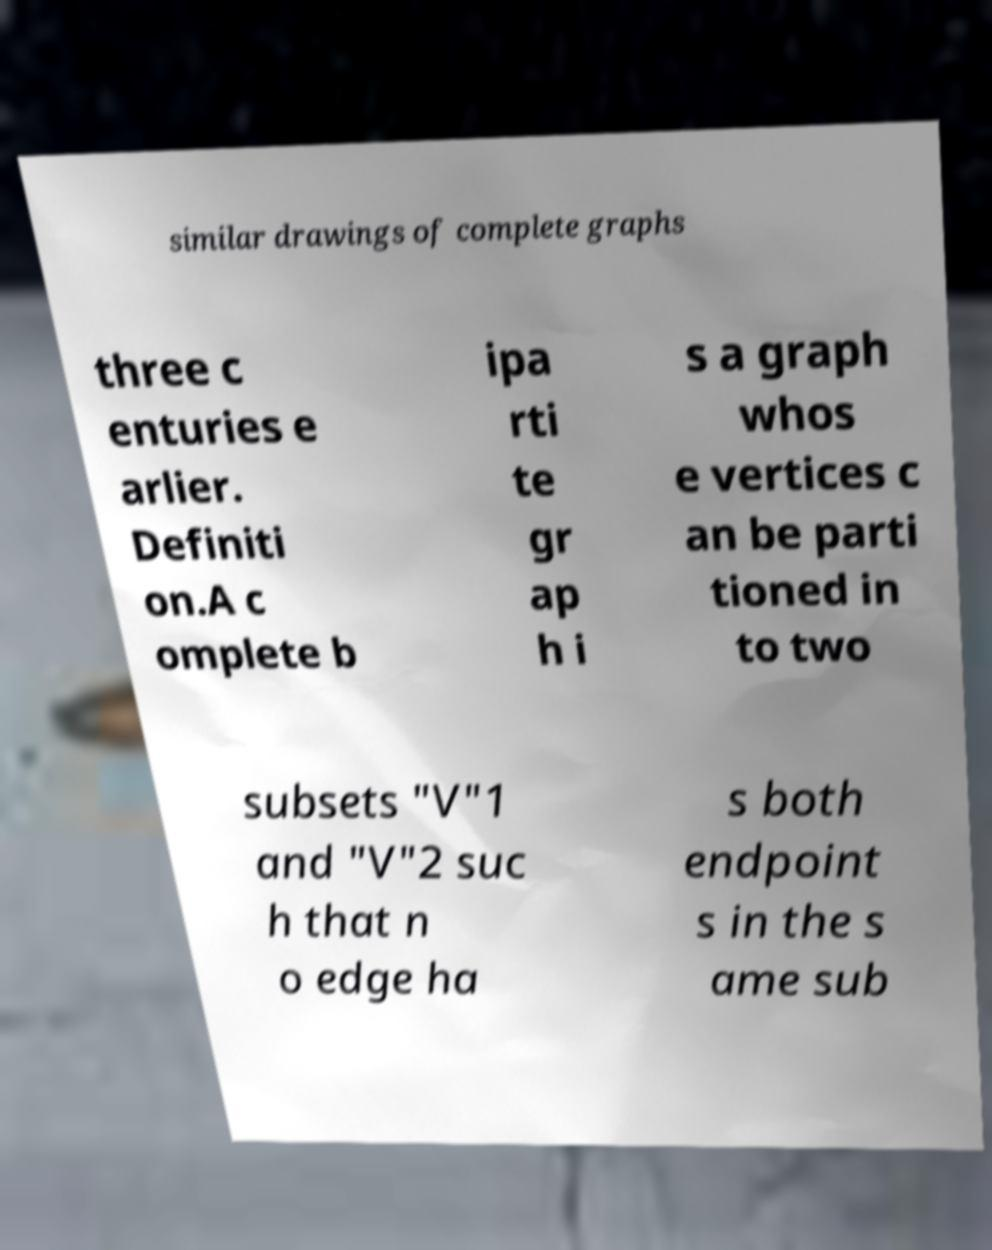Can you accurately transcribe the text from the provided image for me? similar drawings of complete graphs three c enturies e arlier. Definiti on.A c omplete b ipa rti te gr ap h i s a graph whos e vertices c an be parti tioned in to two subsets "V"1 and "V"2 suc h that n o edge ha s both endpoint s in the s ame sub 